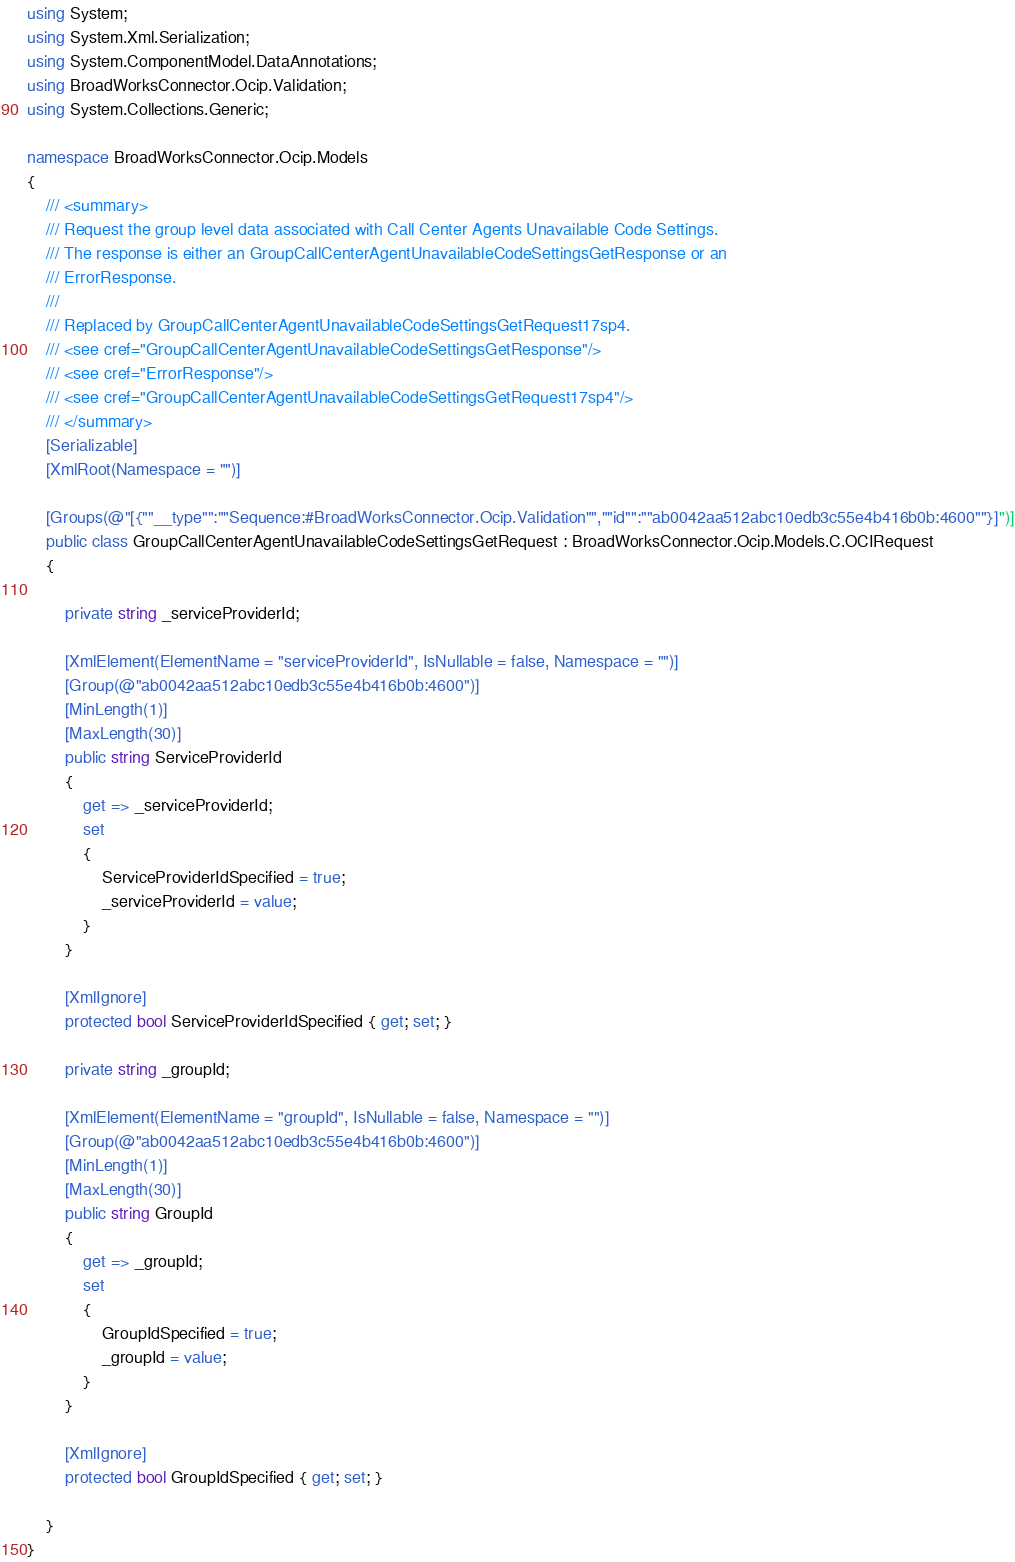<code> <loc_0><loc_0><loc_500><loc_500><_C#_>using System;
using System.Xml.Serialization;
using System.ComponentModel.DataAnnotations;
using BroadWorksConnector.Ocip.Validation;
using System.Collections.Generic;

namespace BroadWorksConnector.Ocip.Models
{
    /// <summary>
    /// Request the group level data associated with Call Center Agents Unavailable Code Settings.
    /// The response is either an GroupCallCenterAgentUnavailableCodeSettingsGetResponse or an
    /// ErrorResponse.
    /// 
    /// Replaced by GroupCallCenterAgentUnavailableCodeSettingsGetRequest17sp4.
    /// <see cref="GroupCallCenterAgentUnavailableCodeSettingsGetResponse"/>
    /// <see cref="ErrorResponse"/>
    /// <see cref="GroupCallCenterAgentUnavailableCodeSettingsGetRequest17sp4"/>
    /// </summary>
    [Serializable]
    [XmlRoot(Namespace = "")]

    [Groups(@"[{""__type"":""Sequence:#BroadWorksConnector.Ocip.Validation"",""id"":""ab0042aa512abc10edb3c55e4b416b0b:4600""}]")]
    public class GroupCallCenterAgentUnavailableCodeSettingsGetRequest : BroadWorksConnector.Ocip.Models.C.OCIRequest
    {

        private string _serviceProviderId;

        [XmlElement(ElementName = "serviceProviderId", IsNullable = false, Namespace = "")]
        [Group(@"ab0042aa512abc10edb3c55e4b416b0b:4600")]
        [MinLength(1)]
        [MaxLength(30)]
        public string ServiceProviderId
        {
            get => _serviceProviderId;
            set
            {
                ServiceProviderIdSpecified = true;
                _serviceProviderId = value;
            }
        }

        [XmlIgnore]
        protected bool ServiceProviderIdSpecified { get; set; }

        private string _groupId;

        [XmlElement(ElementName = "groupId", IsNullable = false, Namespace = "")]
        [Group(@"ab0042aa512abc10edb3c55e4b416b0b:4600")]
        [MinLength(1)]
        [MaxLength(30)]
        public string GroupId
        {
            get => _groupId;
            set
            {
                GroupIdSpecified = true;
                _groupId = value;
            }
        }

        [XmlIgnore]
        protected bool GroupIdSpecified { get; set; }

    }
}
</code> 